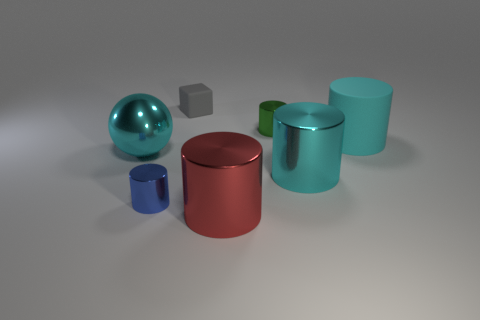Subtract all blue cylinders. How many cylinders are left? 4 Subtract all large red cylinders. How many cylinders are left? 4 Subtract all gray cylinders. Subtract all blue balls. How many cylinders are left? 5 Add 3 large matte things. How many objects exist? 10 Subtract all spheres. How many objects are left? 6 Add 5 cyan shiny spheres. How many cyan shiny spheres exist? 6 Subtract 0 red cubes. How many objects are left? 7 Subtract all cyan metallic things. Subtract all cyan matte cylinders. How many objects are left? 4 Add 7 cyan shiny balls. How many cyan shiny balls are left? 8 